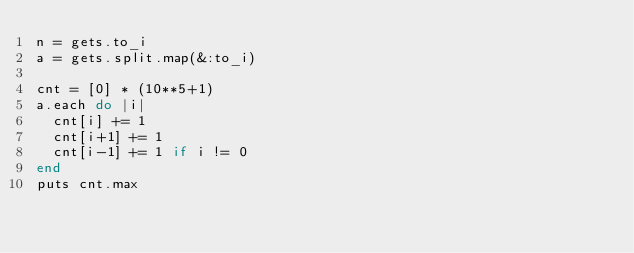<code> <loc_0><loc_0><loc_500><loc_500><_Ruby_>n = gets.to_i
a = gets.split.map(&:to_i)

cnt = [0] * (10**5+1)
a.each do |i|
  cnt[i] += 1
  cnt[i+1] += 1
  cnt[i-1] += 1 if i != 0
end
puts cnt.max</code> 